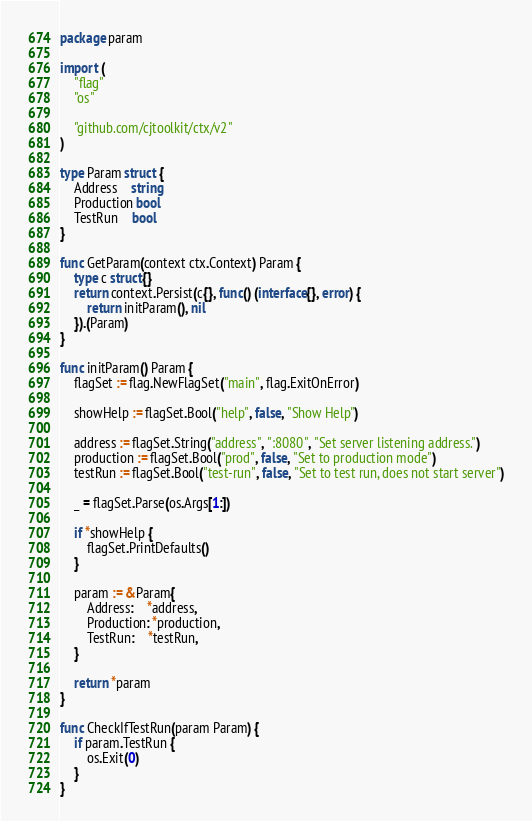Convert code to text. <code><loc_0><loc_0><loc_500><loc_500><_Go_>package param

import (
	"flag"
	"os"

	"github.com/cjtoolkit/ctx/v2"
)

type Param struct {
	Address    string
	Production bool
	TestRun    bool
}

func GetParam(context ctx.Context) Param {
	type c struct{}
	return context.Persist(c{}, func() (interface{}, error) {
		return initParam(), nil
	}).(Param)
}

func initParam() Param {
	flagSet := flag.NewFlagSet("main", flag.ExitOnError)

	showHelp := flagSet.Bool("help", false, "Show Help")

	address := flagSet.String("address", ":8080", "Set server listening address.")
	production := flagSet.Bool("prod", false, "Set to production mode")
	testRun := flagSet.Bool("test-run", false, "Set to test run, does not start server")

	_ = flagSet.Parse(os.Args[1:])

	if *showHelp {
		flagSet.PrintDefaults()
	}

	param := &Param{
		Address:    *address,
		Production: *production,
		TestRun:    *testRun,
	}

	return *param
}

func CheckIfTestRun(param Param) {
	if param.TestRun {
		os.Exit(0)
	}
}
</code> 